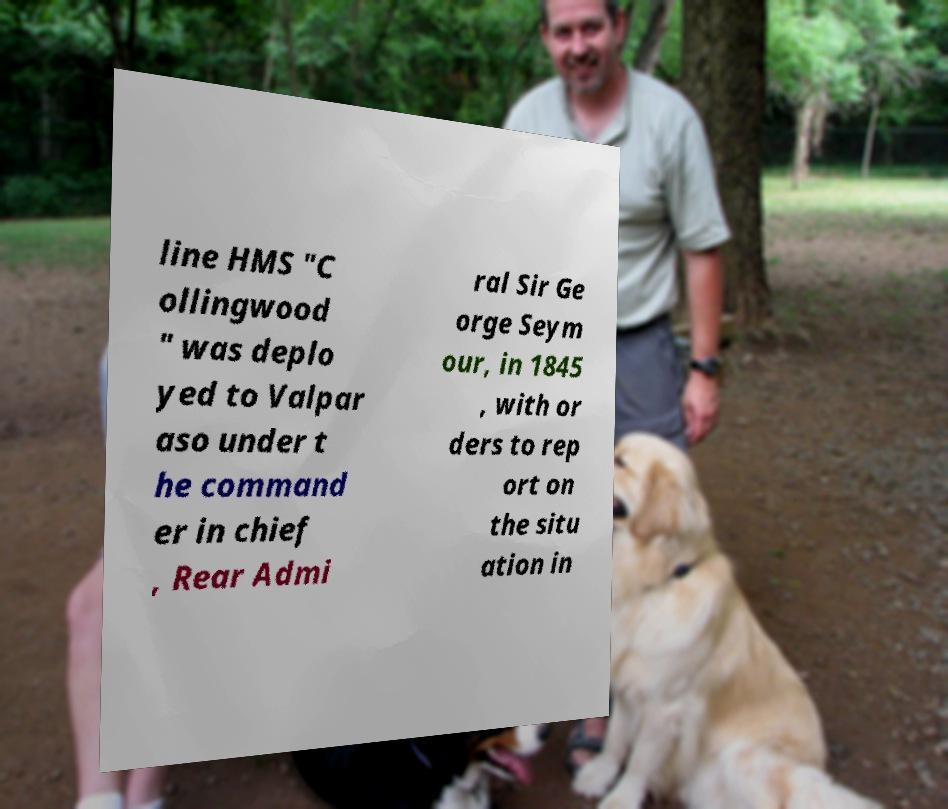Could you assist in decoding the text presented in this image and type it out clearly? line HMS "C ollingwood " was deplo yed to Valpar aso under t he command er in chief , Rear Admi ral Sir Ge orge Seym our, in 1845 , with or ders to rep ort on the situ ation in 